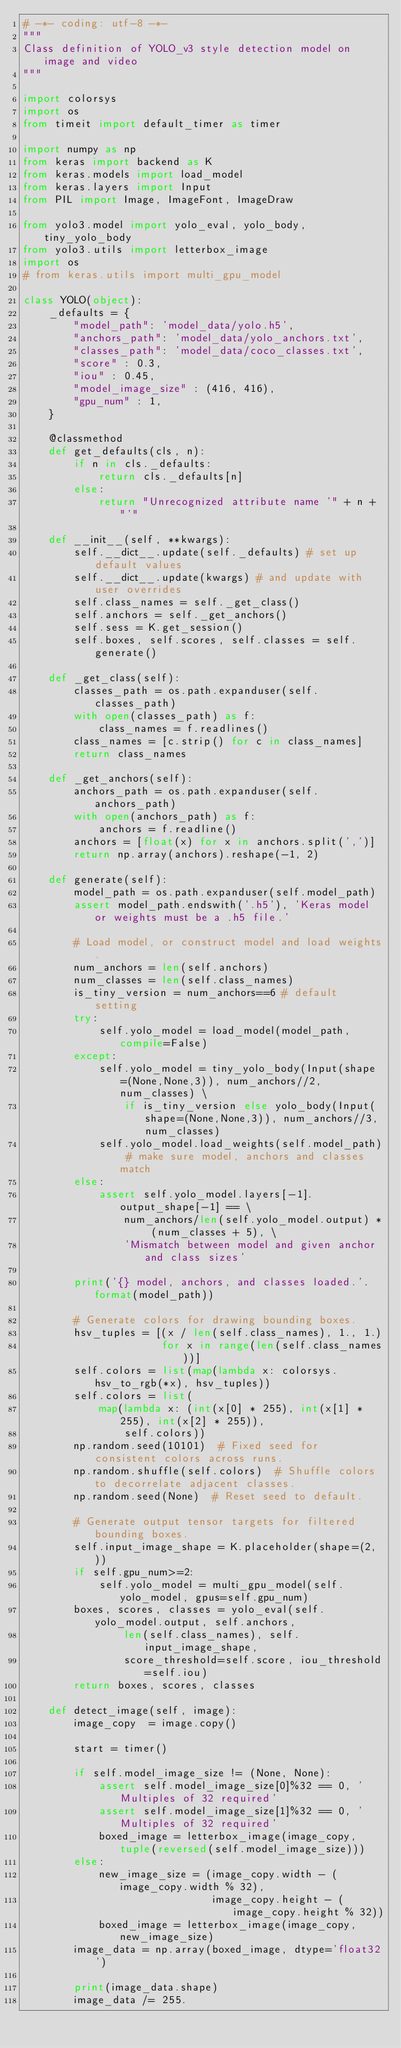Convert code to text. <code><loc_0><loc_0><loc_500><loc_500><_Python_># -*- coding: utf-8 -*-
"""
Class definition of YOLO_v3 style detection model on image and video
"""

import colorsys
import os
from timeit import default_timer as timer

import numpy as np
from keras import backend as K
from keras.models import load_model
from keras.layers import Input
from PIL import Image, ImageFont, ImageDraw

from yolo3.model import yolo_eval, yolo_body, tiny_yolo_body
from yolo3.utils import letterbox_image
import os
# from keras.utils import multi_gpu_model

class YOLO(object):
    _defaults = {
        "model_path": 'model_data/yolo.h5',
        "anchors_path": 'model_data/yolo_anchors.txt',
        "classes_path": 'model_data/coco_classes.txt',
        "score" : 0.3,
        "iou" : 0.45,
        "model_image_size" : (416, 416),
        "gpu_num" : 1,
    }

    @classmethod
    def get_defaults(cls, n):
        if n in cls._defaults:
            return cls._defaults[n]
        else:
            return "Unrecognized attribute name '" + n + "'"

    def __init__(self, **kwargs):
        self.__dict__.update(self._defaults) # set up default values
        self.__dict__.update(kwargs) # and update with user overrides
        self.class_names = self._get_class()
        self.anchors = self._get_anchors()
        self.sess = K.get_session()
        self.boxes, self.scores, self.classes = self.generate()

    def _get_class(self):
        classes_path = os.path.expanduser(self.classes_path)
        with open(classes_path) as f:
            class_names = f.readlines()
        class_names = [c.strip() for c in class_names]
        return class_names

    def _get_anchors(self):
        anchors_path = os.path.expanduser(self.anchors_path)
        with open(anchors_path) as f:
            anchors = f.readline()
        anchors = [float(x) for x in anchors.split(',')]
        return np.array(anchors).reshape(-1, 2)

    def generate(self):
        model_path = os.path.expanduser(self.model_path)
        assert model_path.endswith('.h5'), 'Keras model or weights must be a .h5 file.'

        # Load model, or construct model and load weights.
        num_anchors = len(self.anchors)
        num_classes = len(self.class_names)
        is_tiny_version = num_anchors==6 # default setting
        try:
            self.yolo_model = load_model(model_path, compile=False)
        except:
            self.yolo_model = tiny_yolo_body(Input(shape=(None,None,3)), num_anchors//2, num_classes) \
                if is_tiny_version else yolo_body(Input(shape=(None,None,3)), num_anchors//3, num_classes)
            self.yolo_model.load_weights(self.model_path) # make sure model, anchors and classes match
        else:
            assert self.yolo_model.layers[-1].output_shape[-1] == \
                num_anchors/len(self.yolo_model.output) * (num_classes + 5), \
                'Mismatch between model and given anchor and class sizes'

        print('{} model, anchors, and classes loaded.'.format(model_path))

        # Generate colors for drawing bounding boxes.
        hsv_tuples = [(x / len(self.class_names), 1., 1.)
                      for x in range(len(self.class_names))]
        self.colors = list(map(lambda x: colorsys.hsv_to_rgb(*x), hsv_tuples))
        self.colors = list(
            map(lambda x: (int(x[0] * 255), int(x[1] * 255), int(x[2] * 255)),
                self.colors))
        np.random.seed(10101)  # Fixed seed for consistent colors across runs.
        np.random.shuffle(self.colors)  # Shuffle colors to decorrelate adjacent classes.
        np.random.seed(None)  # Reset seed to default.

        # Generate output tensor targets for filtered bounding boxes.
        self.input_image_shape = K.placeholder(shape=(2, ))
        if self.gpu_num>=2:
            self.yolo_model = multi_gpu_model(self.yolo_model, gpus=self.gpu_num)
        boxes, scores, classes = yolo_eval(self.yolo_model.output, self.anchors,
                len(self.class_names), self.input_image_shape,
                score_threshold=self.score, iou_threshold=self.iou)
        return boxes, scores, classes

    def detect_image(self, image):
        image_copy  = image.copy()

        start = timer()

        if self.model_image_size != (None, None):
            assert self.model_image_size[0]%32 == 0, 'Multiples of 32 required'
            assert self.model_image_size[1]%32 == 0, 'Multiples of 32 required'
            boxed_image = letterbox_image(image_copy, tuple(reversed(self.model_image_size)))
        else:
            new_image_size = (image_copy.width - (image_copy.width % 32),
                              image_copy.height - (image_copy.height % 32))
            boxed_image = letterbox_image(image_copy, new_image_size)
        image_data = np.array(boxed_image, dtype='float32')

        print(image_data.shape)
        image_data /= 255.</code> 